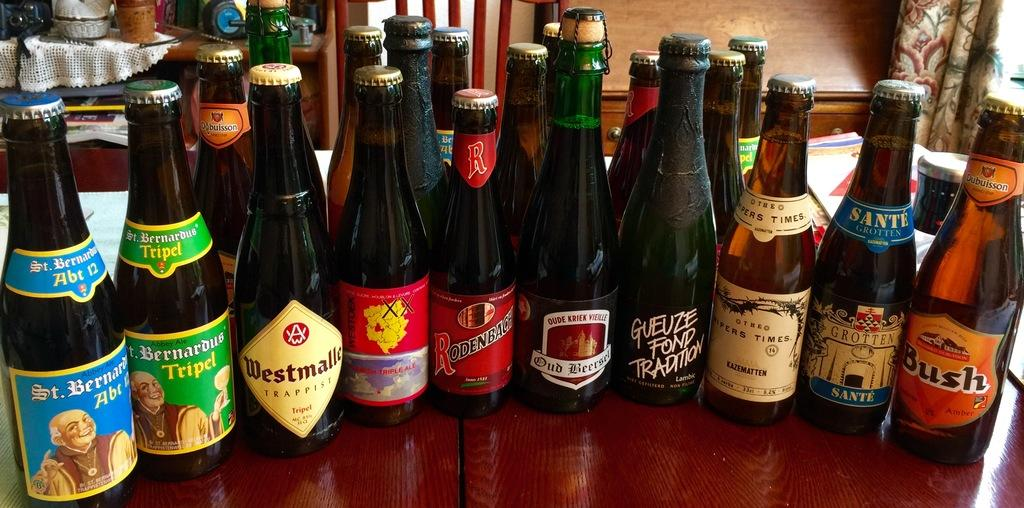What type of items are present in the image? There is a group of alcohol bottles in the image. Where are the alcohol bottles located? The alcohol bottles are present on a table. What type of steel structure can be seen in the image? There is no steel structure present in the image; it features a group of alcohol bottles on a table. What is the time of day depicted in the image? The provided facts do not mention the time of day, so it cannot be determined from the image. 